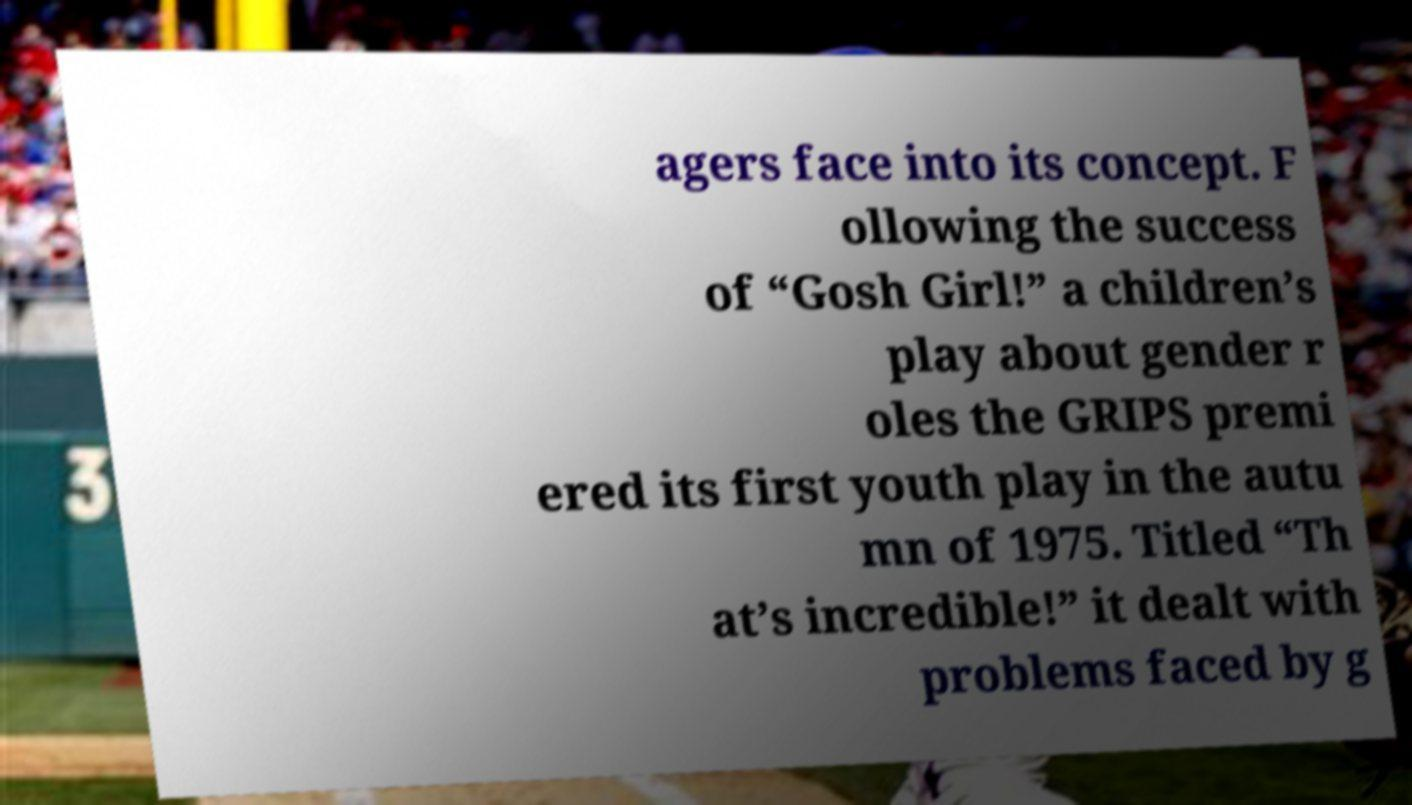What messages or text are displayed in this image? I need them in a readable, typed format. agers face into its concept. F ollowing the success of “Gosh Girl!” a children’s play about gender r oles the GRIPS premi ered its first youth play in the autu mn of 1975. Titled “Th at’s incredible!” it dealt with problems faced by g 